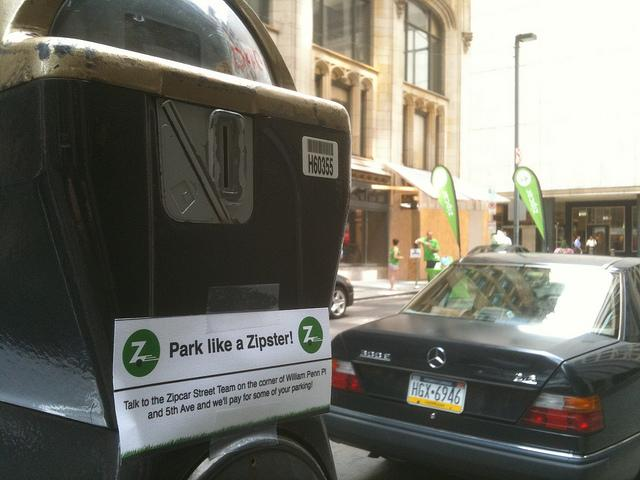What make of car can be seen next to the parking meter? mercedes 